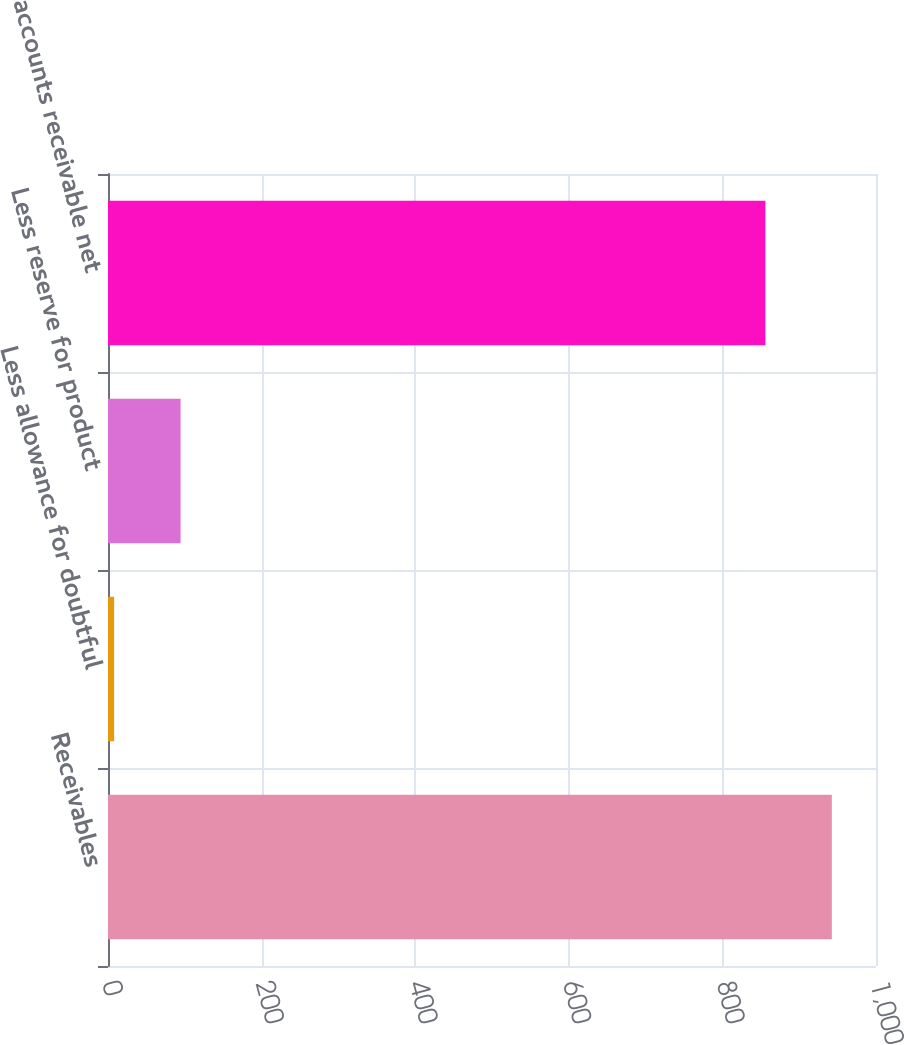Convert chart to OTSL. <chart><loc_0><loc_0><loc_500><loc_500><bar_chart><fcel>Receivables<fcel>Less allowance for doubtful<fcel>Less reserve for product<fcel>Trade accounts receivable net<nl><fcel>942.5<fcel>8<fcel>94.5<fcel>856<nl></chart> 